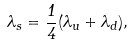<formula> <loc_0><loc_0><loc_500><loc_500>\lambda _ { s } = \frac { 1 } { 4 } ( \lambda _ { u } + \lambda _ { d } ) ,</formula> 